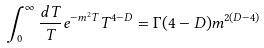<formula> <loc_0><loc_0><loc_500><loc_500>\int _ { 0 } ^ { \infty } { \frac { d T } { T } } e ^ { - m ^ { 2 } T } T ^ { 4 - D } = \Gamma ( 4 - D ) m ^ { 2 ( D - 4 ) }</formula> 